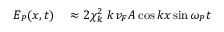Convert formula to latex. <formula><loc_0><loc_0><loc_500><loc_500>\begin{array} { r l } { E _ { P } ( x , t ) } & \approx 2 \chi _ { k } ^ { 2 } \ k v _ { F } A \cos k x \sin \omega _ { P } t } \end{array}</formula> 